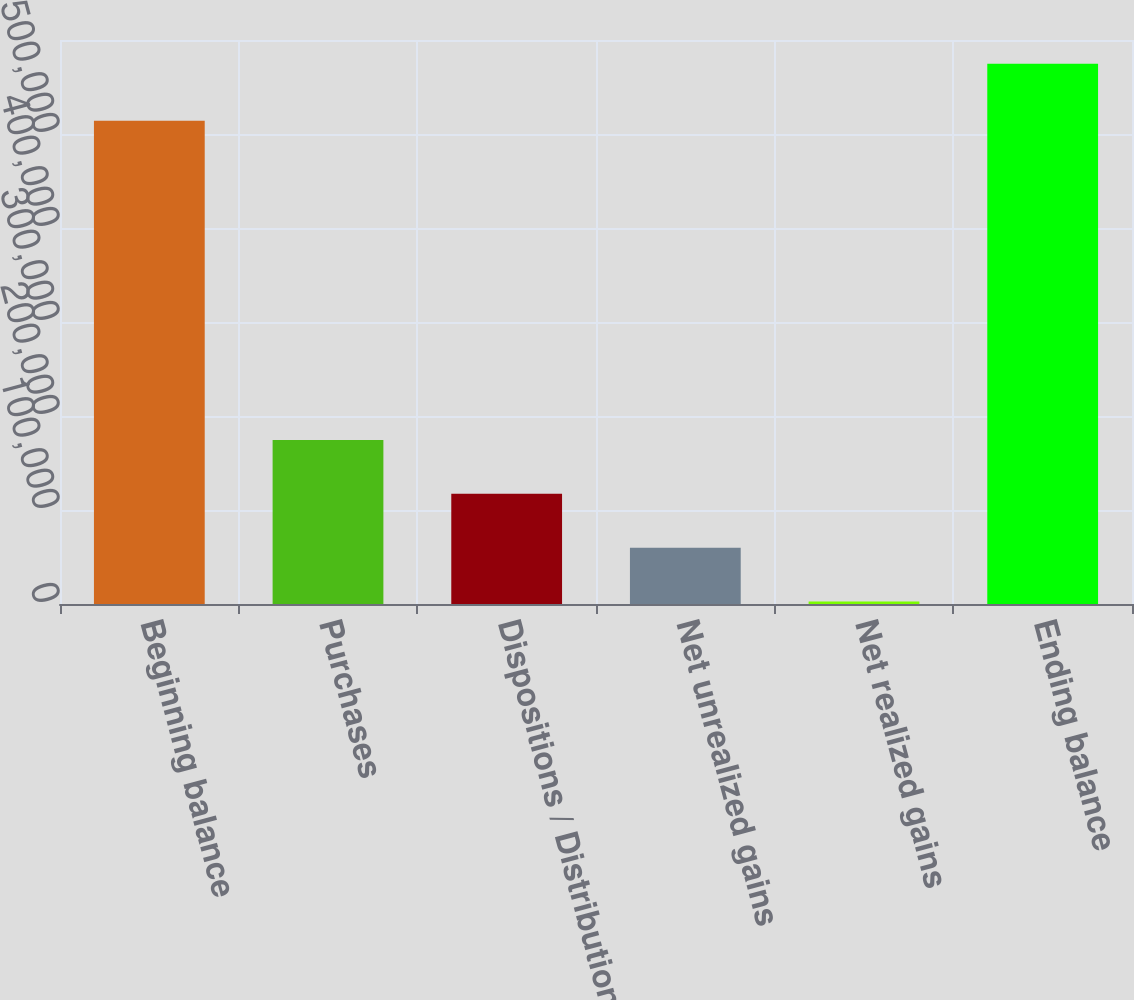Convert chart to OTSL. <chart><loc_0><loc_0><loc_500><loc_500><bar_chart><fcel>Beginning balance<fcel>Purchases<fcel>Dispositions / Distributions<fcel>Net unrealized gains<fcel>Net realized gains<fcel>Ending balance<nl><fcel>513973<fcel>174358<fcel>117158<fcel>59957.4<fcel>2757<fcel>574761<nl></chart> 